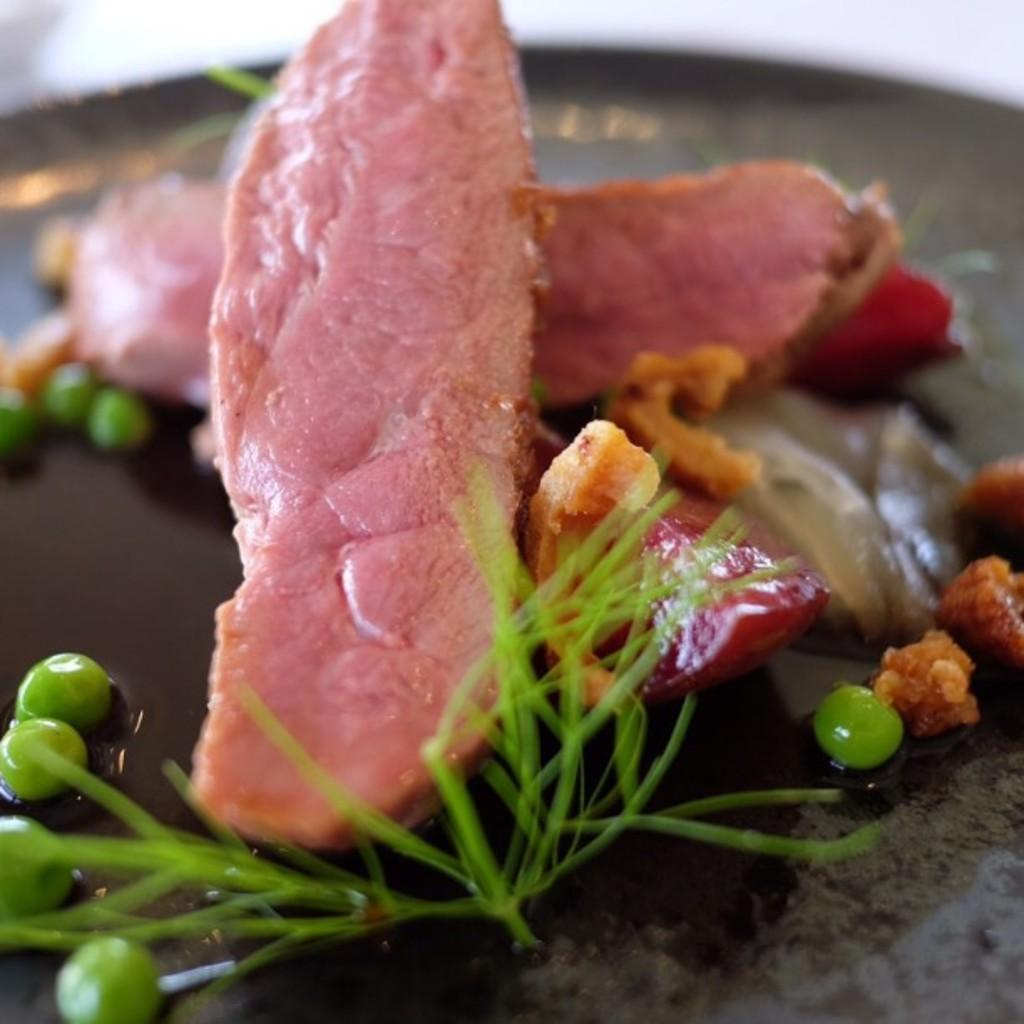What is the main object in the image? There is a pan in the image. What is inside the pan? The pan contains peas grains, slices of meat, pieces of fried food, and leaf garnish. What type of gate can be seen in the image? There is no gate present in the image; it features a pan with various food items. Can you describe the dock in the image? There is no dock present in the image; it features a pan with various food items. 